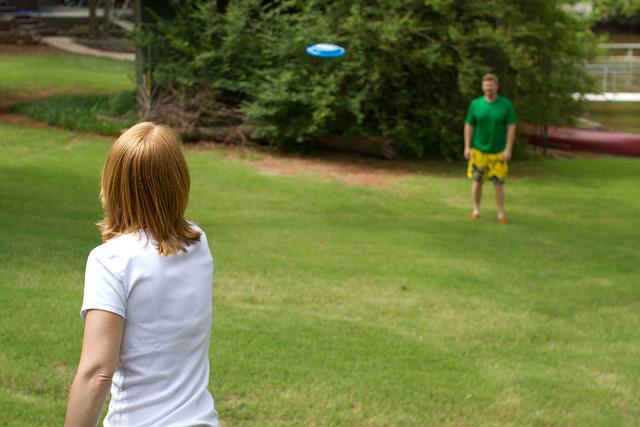What sport is the woman playing?
Keep it brief. Frisbee. Did the man catch what the woman threw at him?
Quick response, please. Yes. What are the children doing?
Keep it brief. Frisbee. What sport is this?
Quick response, please. Frisbee. What color is the Frisbee?
Be succinct. Blue. What color is the frisbee?
Short answer required. Blue. What are the people throwing to each other?
Short answer required. Frisbee. 